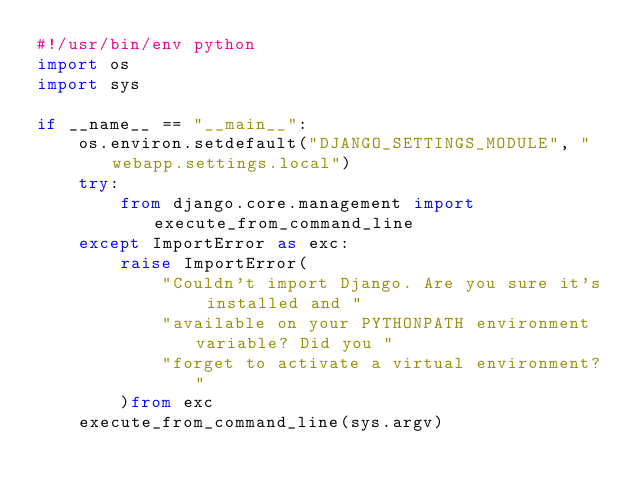<code> <loc_0><loc_0><loc_500><loc_500><_Python_>#!/usr/bin/env python
import os
import sys

if __name__ == "__main__":
    os.environ.setdefault("DJANGO_SETTINGS_MODULE", "webapp.settings.local")
    try:
        from django.core.management import execute_from_command_line
    except ImportError as exc:
        raise ImportError(
            "Couldn't import Django. Are you sure it's installed and "
            "available on your PYTHONPATH environment variable? Did you "
            "forget to activate a virtual environment?"
        )from exc
    execute_from_command_line(sys.argv)
</code> 